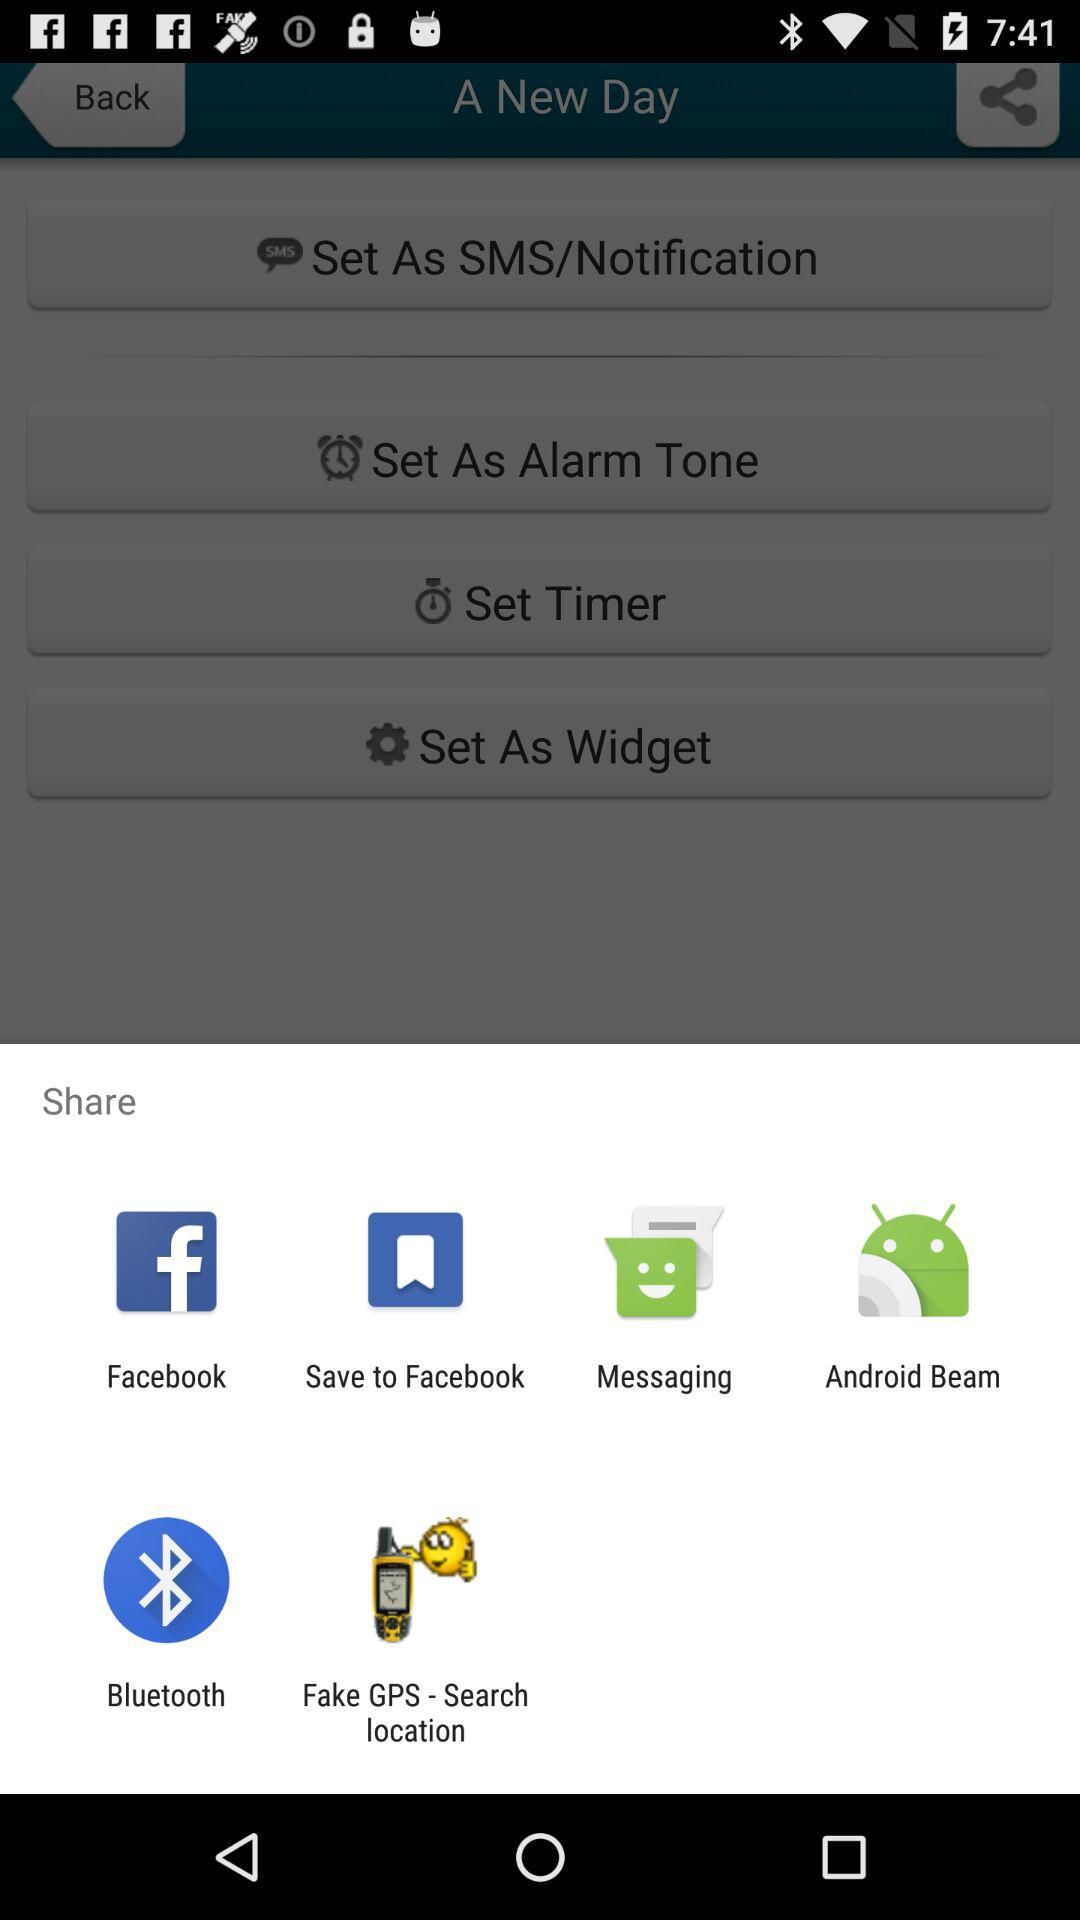What accounts can I use to sign up?
When the provided information is insufficient, respond with <no answer>. <no answer> 